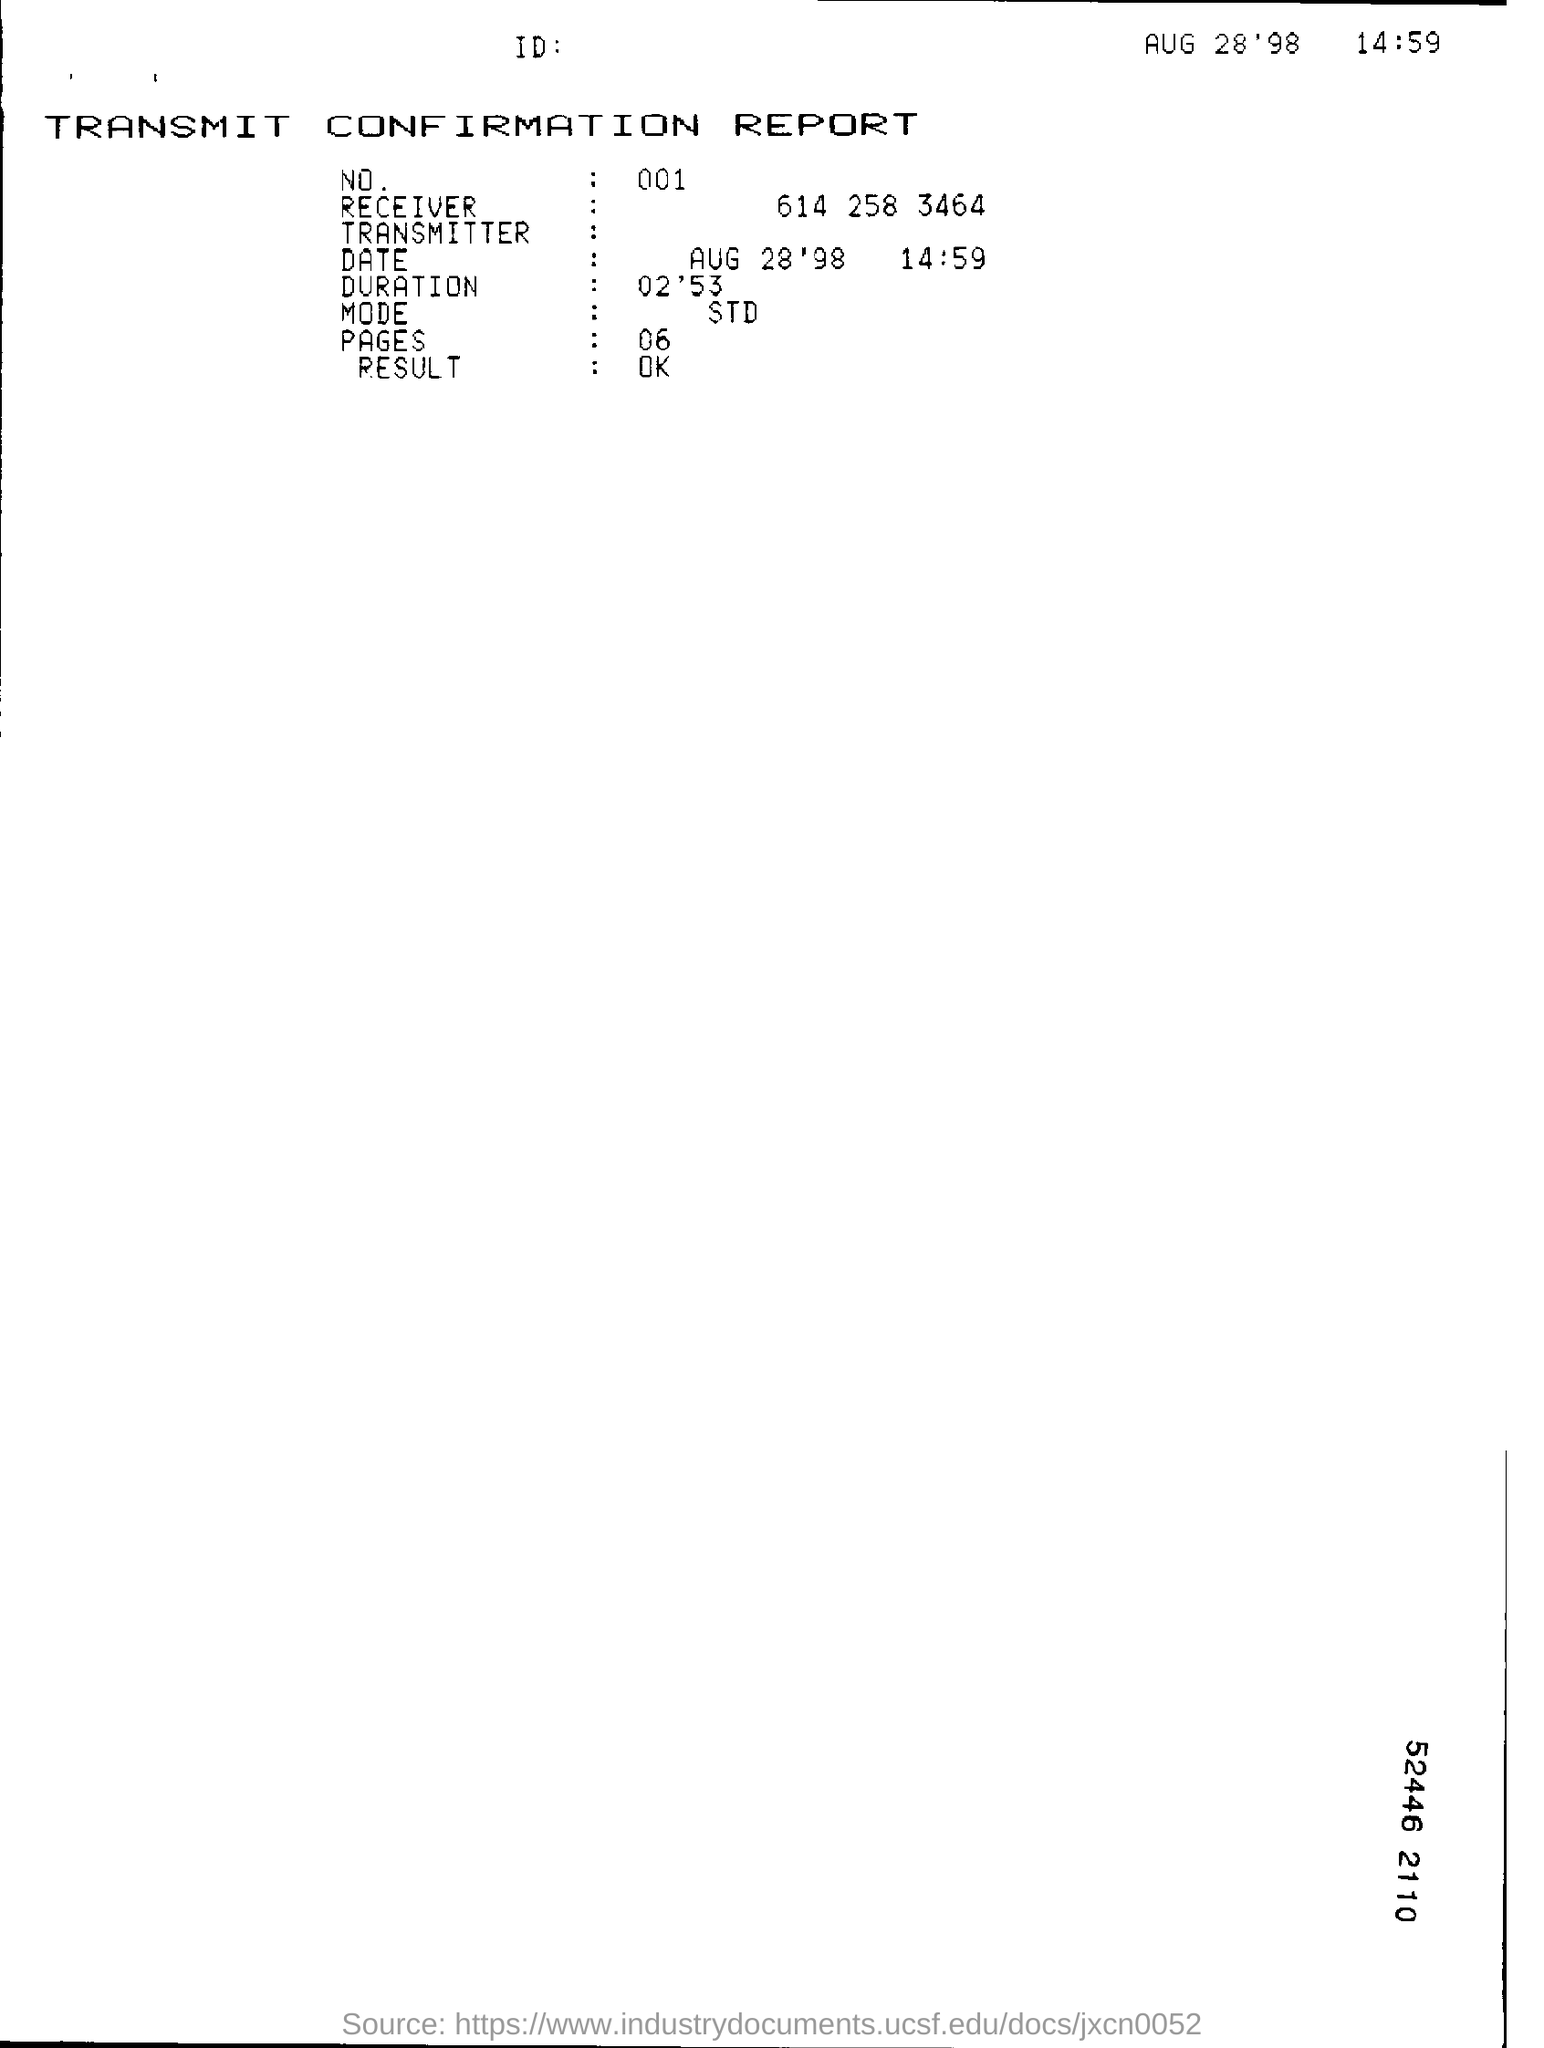Specify some key components in this picture. It is not mentioned in this document" is equivalent to "The document does not contain any mention of it. The duration time mentioned in this document is 2 minutes and 53 seconds. The date mentioned in this document is August 28, 1998. The result mentioned in this document is OK. The document mentions the concept of mode, specifically asking "what is the mode? 